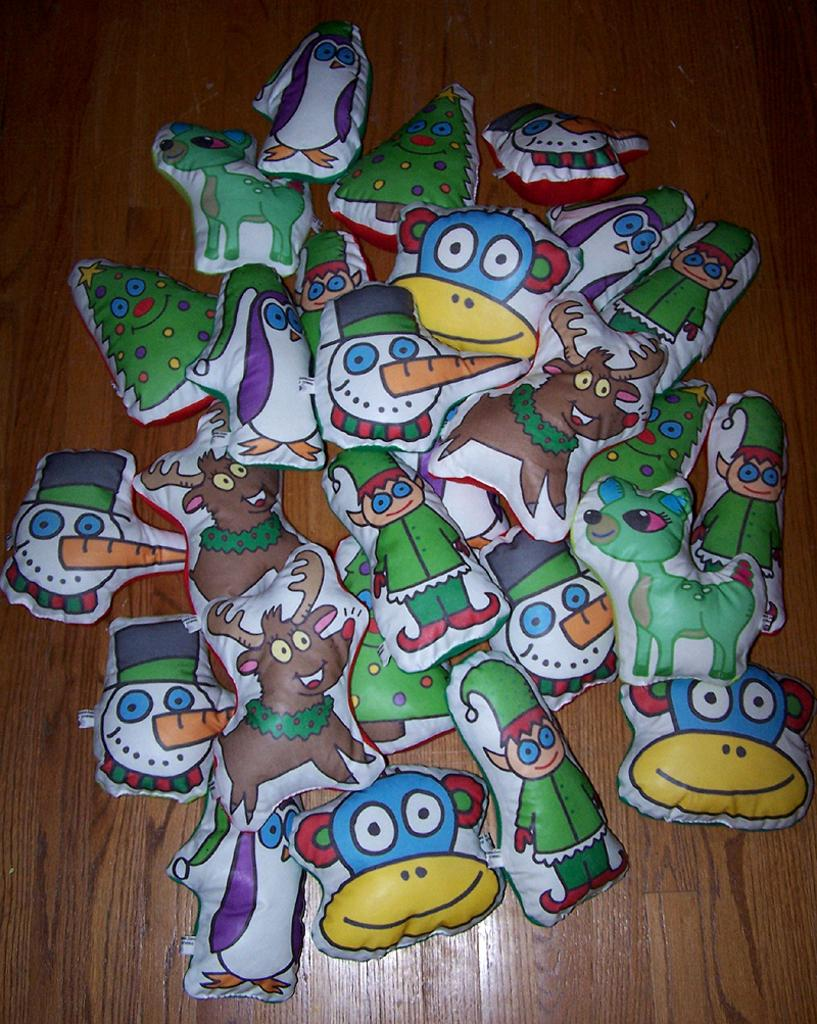What type of toys are present in the image? There are many air pump inflatable toys in the image. What is the surface on which the toys are placed? The toys are placed on a wooden surface. What type of brush is used to clean the tin bottle in the image? There is no brush or tin bottle present in the image. 